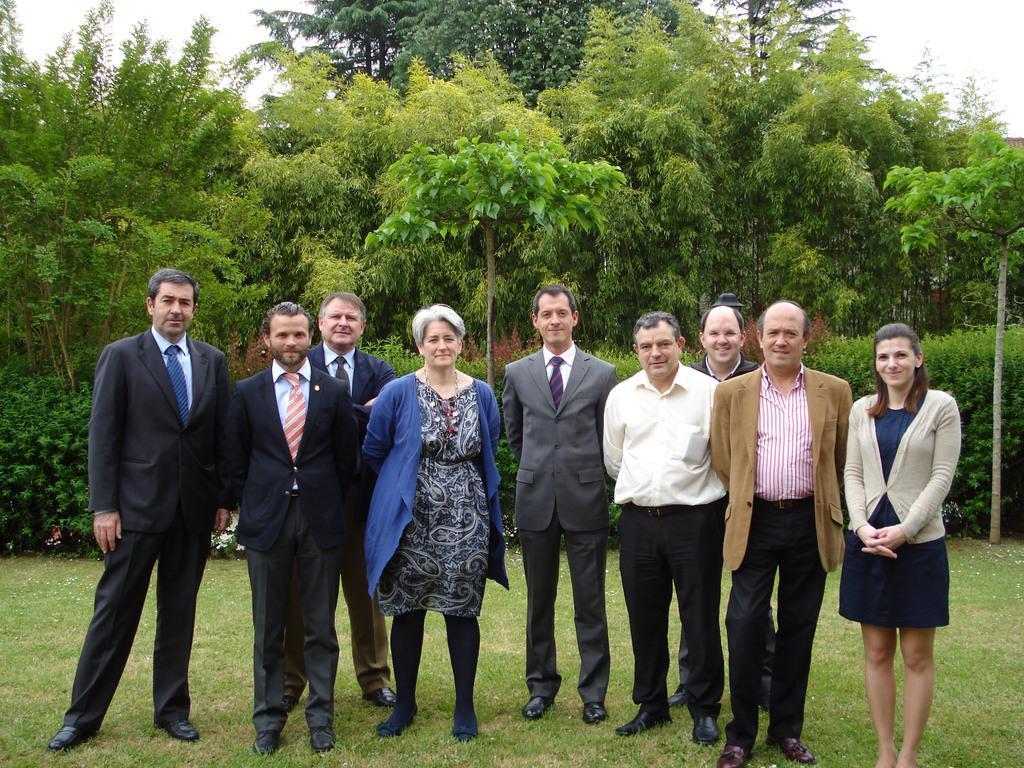Could you give a brief overview of what you see in this image? In the foreground of the picture there are people standing and there is grass. In the background there are trees and plants. Sky is cloudy. 